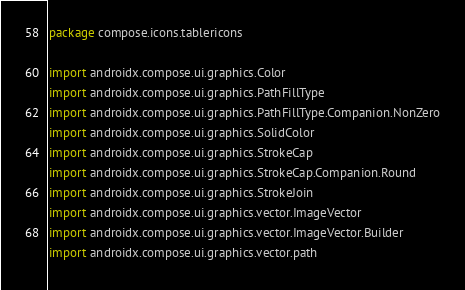Convert code to text. <code><loc_0><loc_0><loc_500><loc_500><_Kotlin_>package compose.icons.tablericons

import androidx.compose.ui.graphics.Color
import androidx.compose.ui.graphics.PathFillType
import androidx.compose.ui.graphics.PathFillType.Companion.NonZero
import androidx.compose.ui.graphics.SolidColor
import androidx.compose.ui.graphics.StrokeCap
import androidx.compose.ui.graphics.StrokeCap.Companion.Round
import androidx.compose.ui.graphics.StrokeJoin
import androidx.compose.ui.graphics.vector.ImageVector
import androidx.compose.ui.graphics.vector.ImageVector.Builder
import androidx.compose.ui.graphics.vector.path</code> 